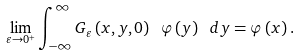Convert formula to latex. <formula><loc_0><loc_0><loc_500><loc_500>\lim _ { \varepsilon \rightarrow 0 ^ { + } } \int _ { - \infty } ^ { \infty } G _ { \varepsilon } \left ( x , y , 0 \right ) \ \varphi \left ( y \right ) \ d y = \varphi \left ( x \right ) .</formula> 